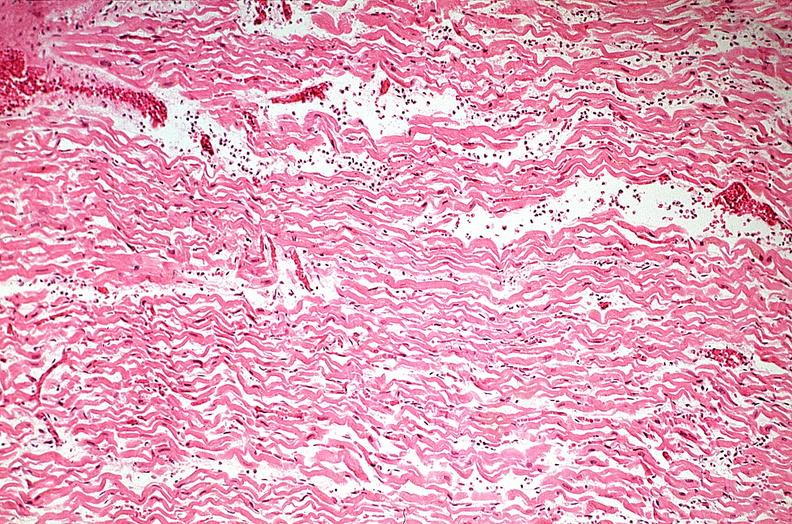does quite good liver show heart, myocardial infarction, wavey fiber change, necrtosis, hemorrhage, and dissection?
Answer the question using a single word or phrase. No 